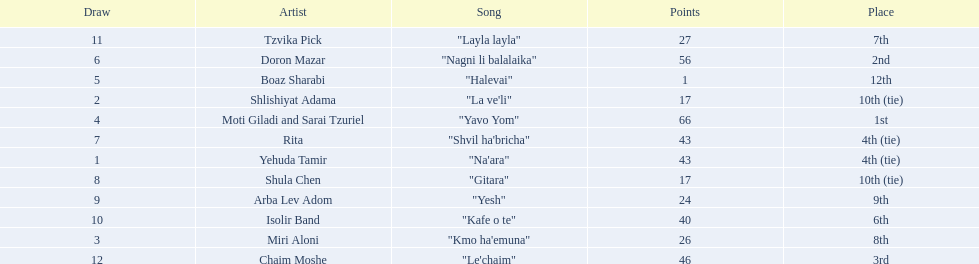What artist received the least amount of points in the competition? Boaz Sharabi. 